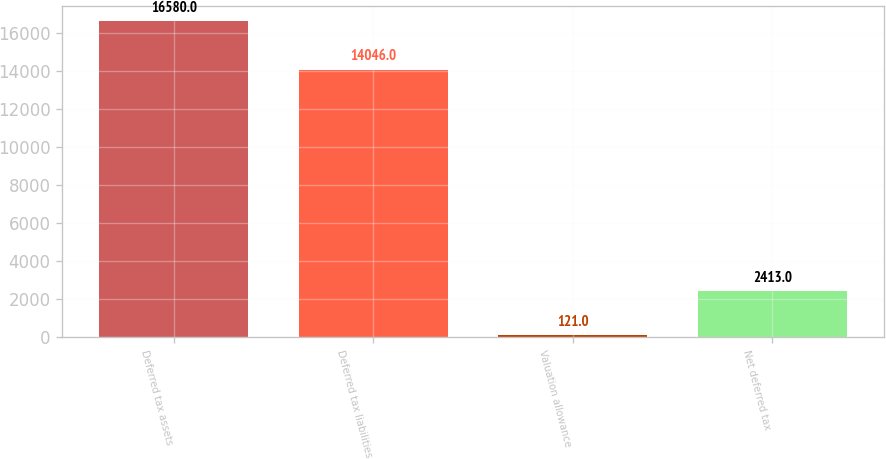<chart> <loc_0><loc_0><loc_500><loc_500><bar_chart><fcel>Deferred tax assets<fcel>Deferred tax liabilities<fcel>Valuation allowance<fcel>Net deferred tax<nl><fcel>16580<fcel>14046<fcel>121<fcel>2413<nl></chart> 